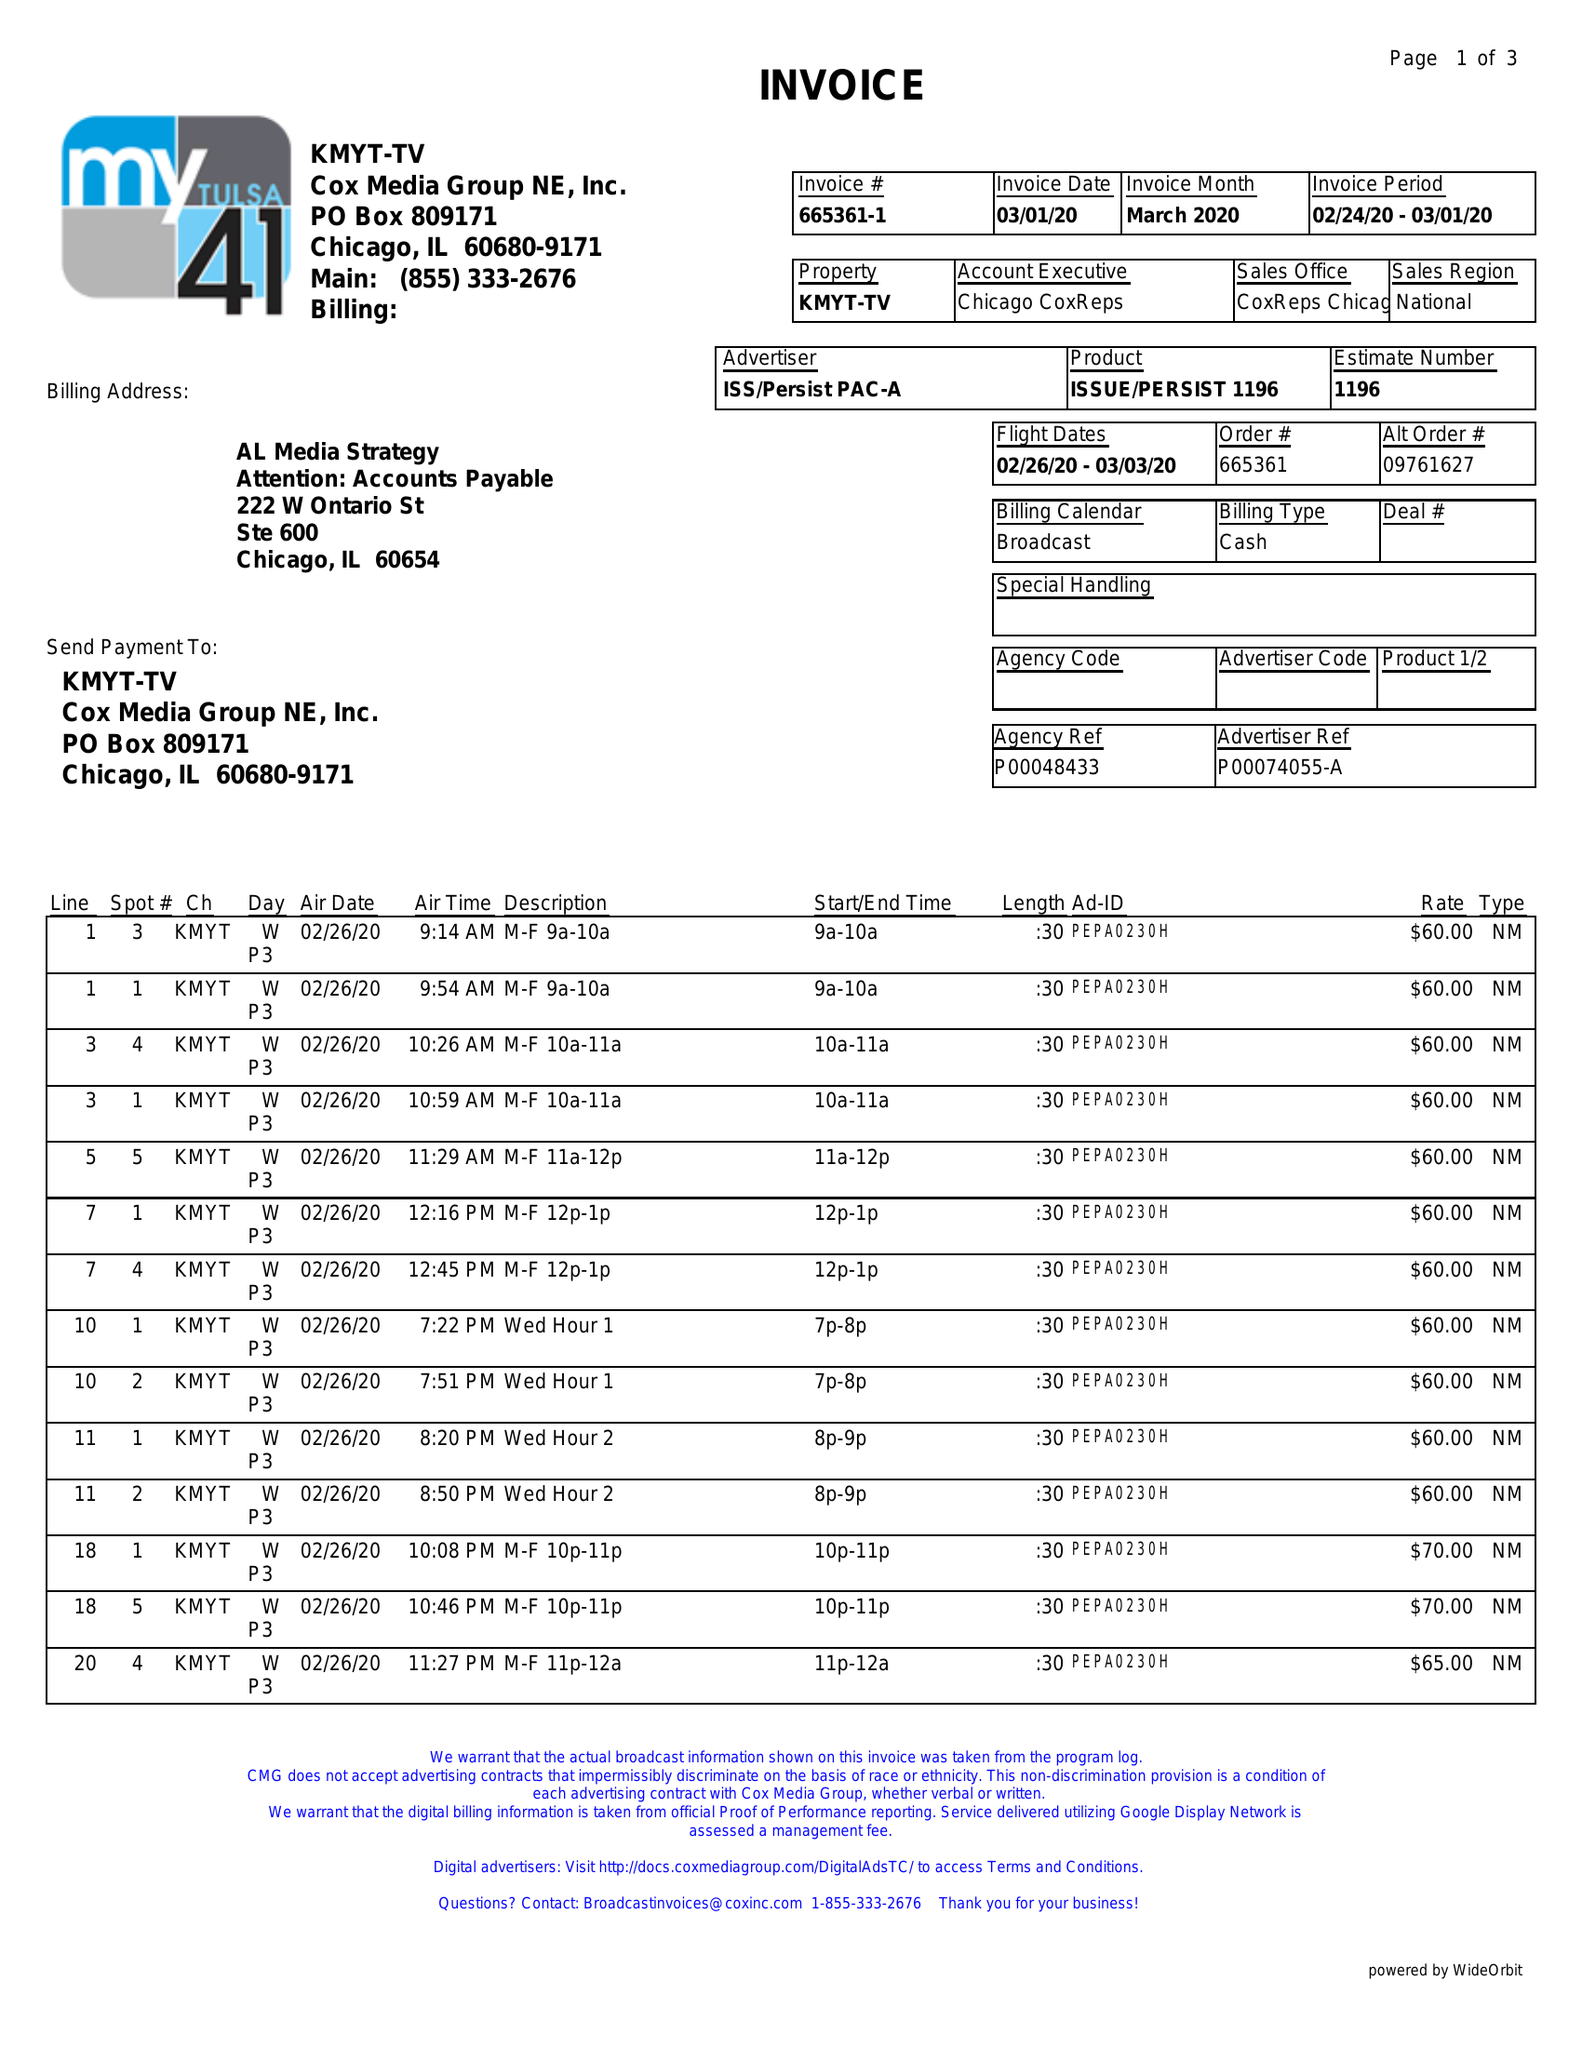What is the value for the flight_to?
Answer the question using a single word or phrase. 03/03/20 